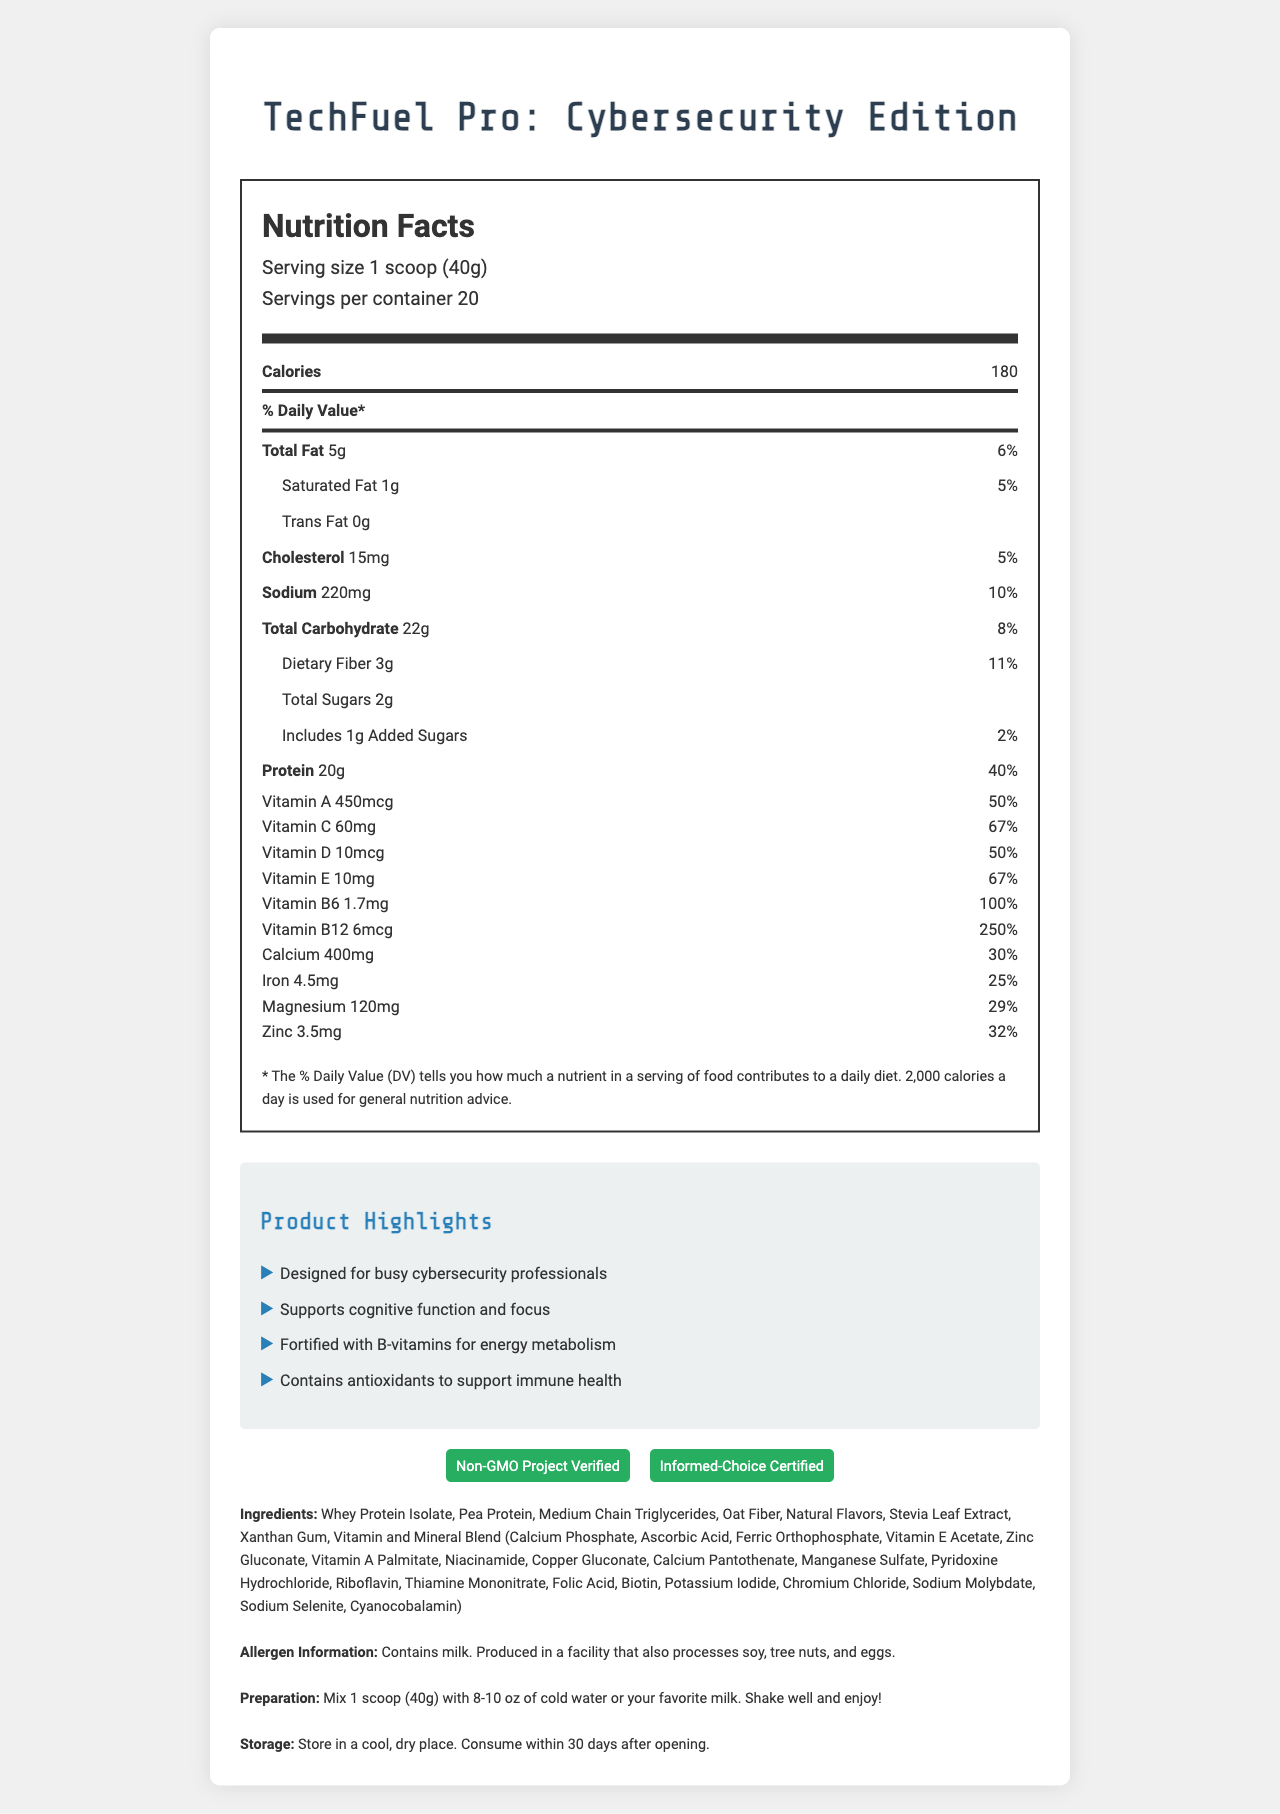what is the serving size? The serving size is stated as "1 scoop (40g)" in the serving info section.
Answer: 1 scoop (40g) how many calories are there per serving? The label shows that each serving contains 180 calories.
Answer: 180 what is the total fat content per serving? The total fat content listed is 5g per serving.
Answer: 5g what percentage of the daily value is the protein content? The protein content per serving provides 40% of the daily value.
Answer: 40% what allergens are contained in the product? The allergen information states "Contains milk. Produced in a facility that also processes soy, tree nuts, and eggs."
Answer: Milk which vitamin has the highest daily value percentage per serving? A. Vitamin A B. Vitamin C C. Vitamin B6 D. Vitamin B12 Vitamin B12 has the highest daily value of 250%.
Answer: D. Vitamin B12 what are the certifications for this product? A. Gluten-Free B. Non-GMO Project Verified C. USDA Organic D. Informed-Choice Certified The product is certified as "Non-GMO Project Verified" and "Informed-Choice Certified."
Answer: B, D is this product designed for busy cybersecurity professionals? One of the marketing claims states "Designed for busy cybersecurity professionals."
Answer: Yes what is the main idea of this document? The document highlights the nutritional information, vitamins and minerals, marketing claims, allergens, preparation, and storage instructions for the product.
Answer: A detailed nutrition facts label for the TechFuel Pro: Cybersecurity Edition meal replacement shake aimed at busy tech professionals can the document determine if the product is suitable for vegans? The document lists "whey protein isolate" as an ingredient, which is a dairy product, making it unsuitable for vegans. However, no explicit suitability for vegans is mentioned.
Answer: Cannot be determined 